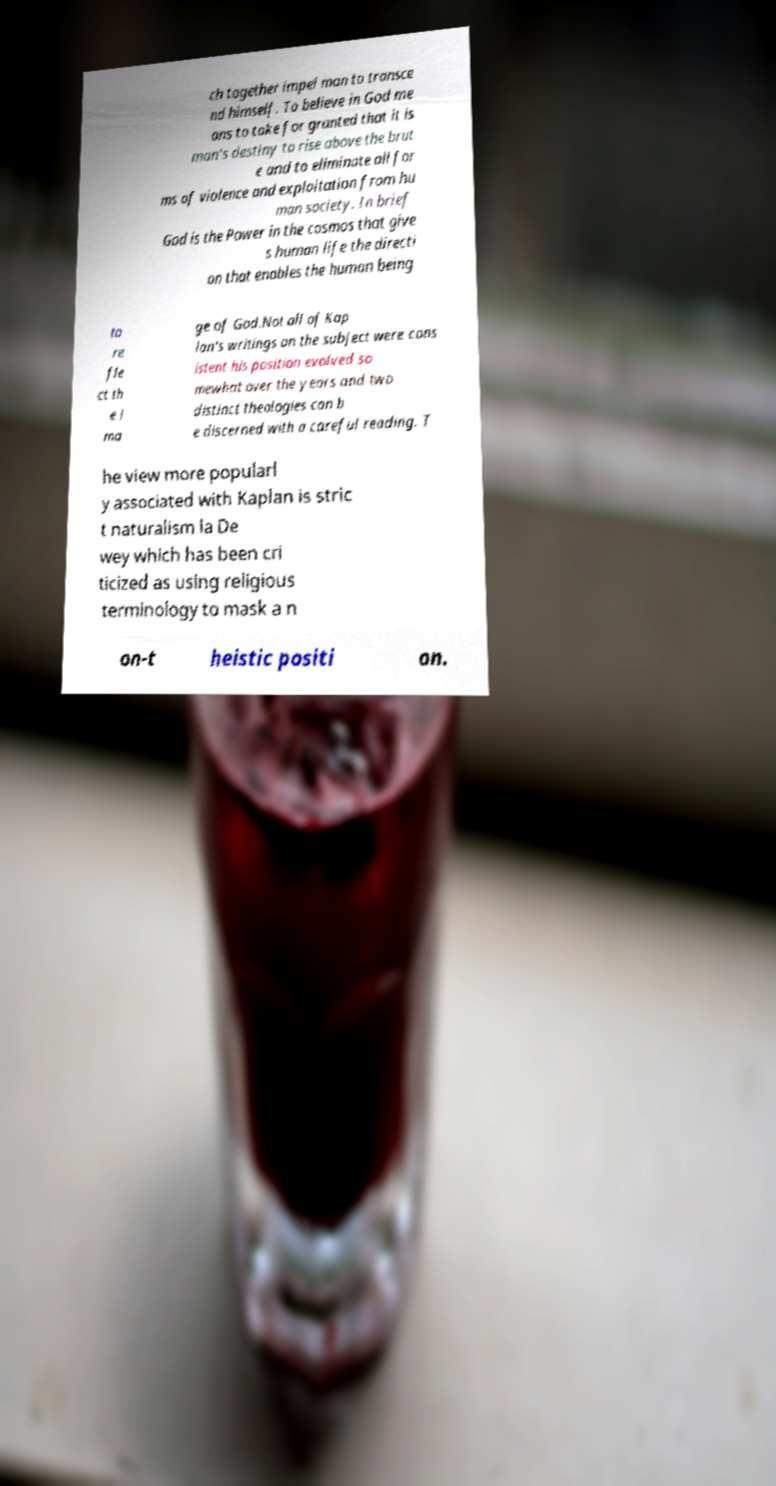There's text embedded in this image that I need extracted. Can you transcribe it verbatim? ch together impel man to transce nd himself. To believe in God me ans to take for granted that it is man's destiny to rise above the brut e and to eliminate all for ms of violence and exploitation from hu man society. In brief God is the Power in the cosmos that give s human life the directi on that enables the human being to re fle ct th e i ma ge of God.Not all of Kap lan's writings on the subject were cons istent his position evolved so mewhat over the years and two distinct theologies can b e discerned with a careful reading. T he view more popularl y associated with Kaplan is stric t naturalism la De wey which has been cri ticized as using religious terminology to mask a n on-t heistic positi on. 